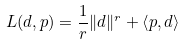<formula> <loc_0><loc_0><loc_500><loc_500>L ( d , p ) = \frac { 1 } { r } \| d \| ^ { r } + \left \langle p , d \right \rangle</formula> 